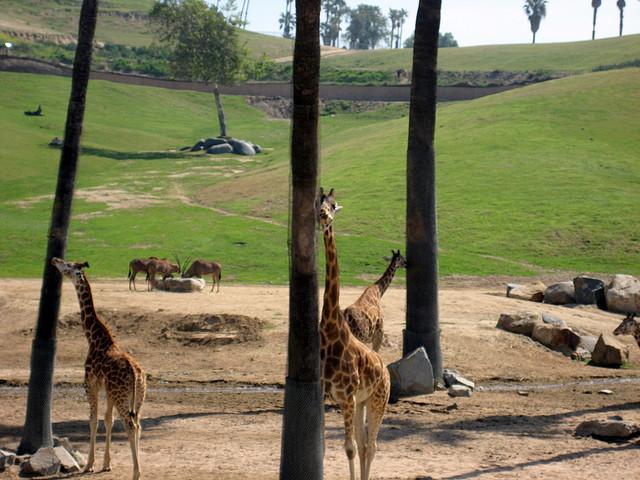Is this a bamboo forest?
Quick response, please. No. Are the animals in the zoo?
Write a very short answer. Yes. Is the land level?
Keep it brief. No. What are the animals in the background?
Write a very short answer. Elk. 